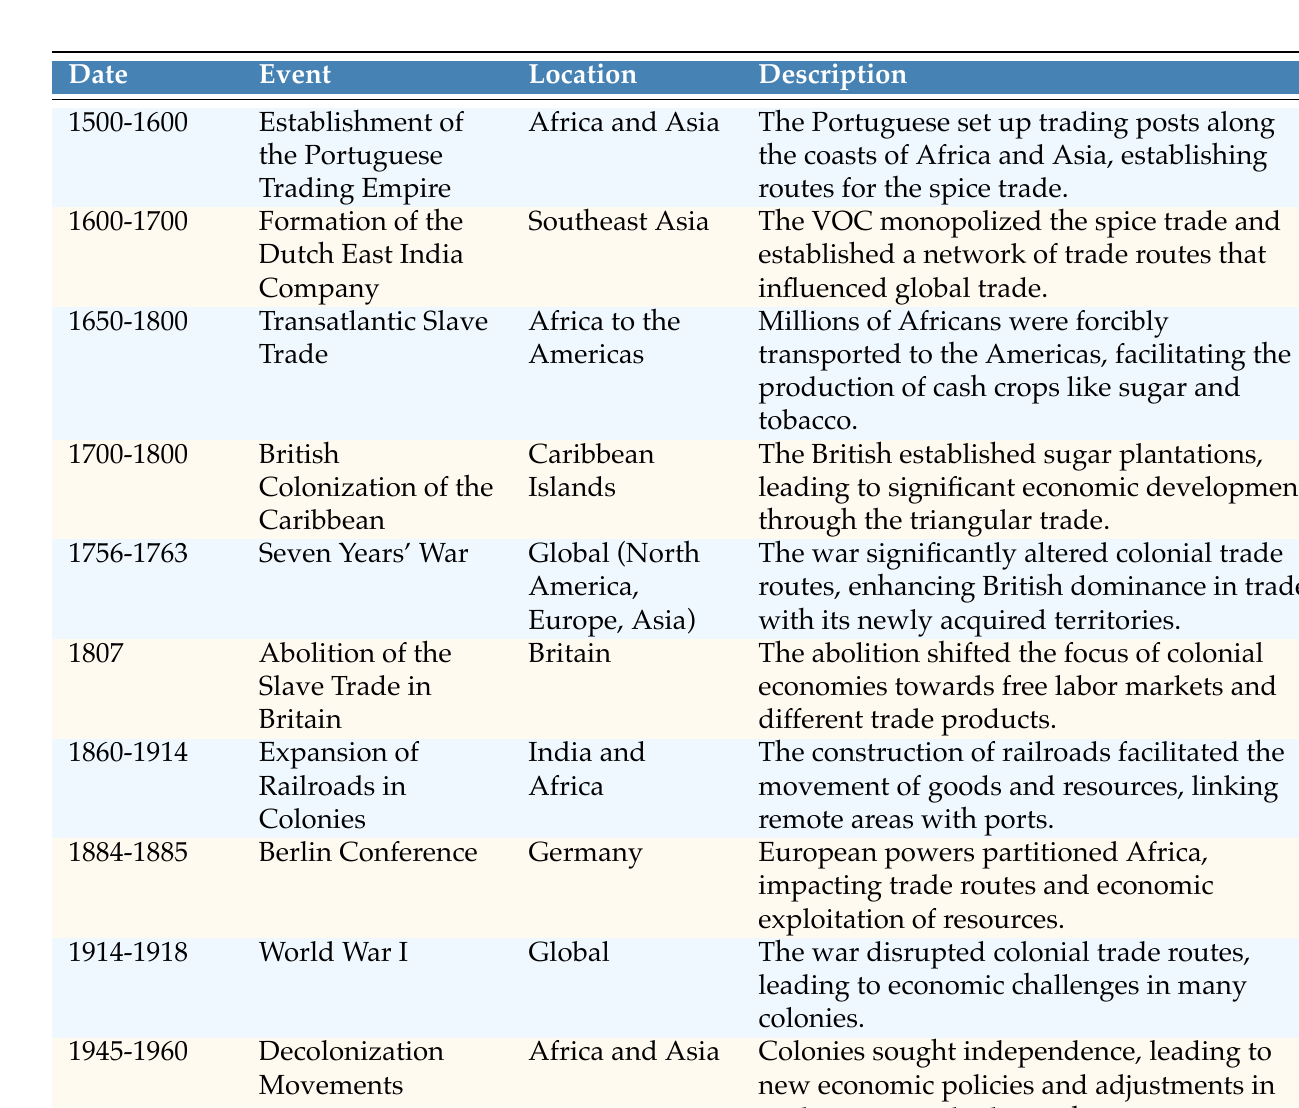What event occurred between 1500 and 1600 related to trade? According to the table, the event listed for this time period is the "Establishment of the Portuguese Trading Empire," which involved setting up trading posts along the coasts of Africa and Asia for the spice trade.
Answer: Establishment of the Portuguese Trading Empire Which region saw the impact of the Transatlantic Slave Trade? The table states that the Transatlantic Slave Trade occurred from Africa to the Americas, meaning this was the region that experienced its effects.
Answer: Africa to the Americas Was the British Colonization of the Caribbean associated with sugar plantations? Yes, the description in the table confirms that British colonization involved the establishment of sugar plantations, significantly contributing to economic development through triangular trade.
Answer: Yes How many years did the Seven Years' War influence trade routes? The table indicates that the Seven Years' War lasted from 1756 to 1763, which is a span of 7 years (1763 - 1756 = 7).
Answer: 7 years What significant shift took place in 1807 concerning the slave trade? The table indicates that in 1807, the "Abolition of the Slave Trade in Britain" occurred, which meant a shift in focus towards free labor markets and different trade products.
Answer: Shifted focus towards free labor markets What were the two primary regions affected by the Expansion of Railroads in Colonies? Referring to the table, the Expansion of Railroads in Colonies impacted India and Africa, facilitating the movement of goods and resources.
Answer: India and Africa Did the Berlin Conference influence economic exploitation? Yes, according to the table, the Berlin Conference involved partitioning Africa, which impacted trade routes and allowed for economic exploitation of resources.
Answer: Yes Between what years did the Decolonization Movements occur? The table specifies that Decolonization Movements took place from 1945 to 1960, indicating these are the years during which colonies sought independence.
Answer: 1945 to 1960 How did World War I affect colonial trade routes? Based on the table, World War I disrupted colonial trade routes, leading to various economic challenges in many colonies. This indicates that the war had a significant impact on trade activities.
Answer: Disrupted colonial trade routes 